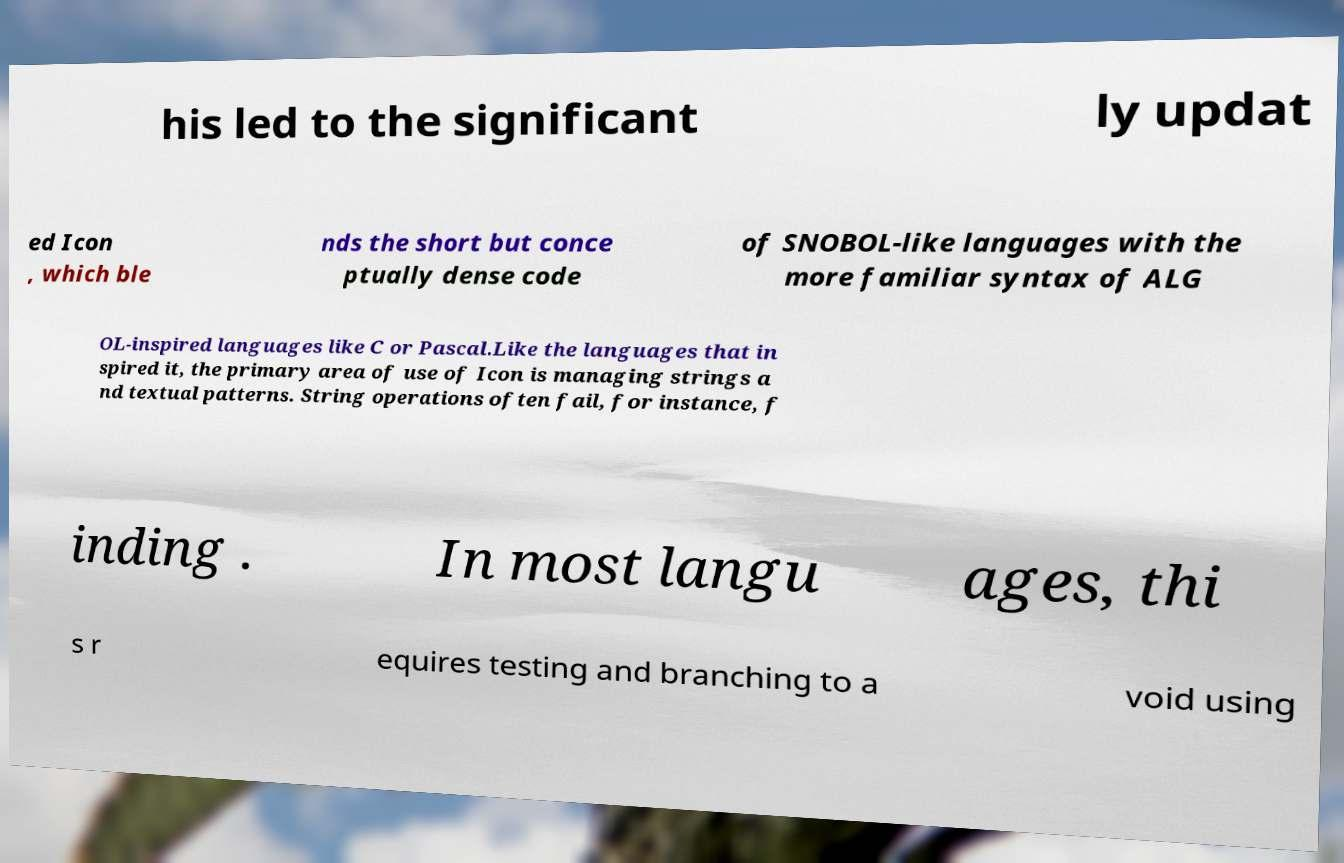There's text embedded in this image that I need extracted. Can you transcribe it verbatim? his led to the significant ly updat ed Icon , which ble nds the short but conce ptually dense code of SNOBOL-like languages with the more familiar syntax of ALG OL-inspired languages like C or Pascal.Like the languages that in spired it, the primary area of use of Icon is managing strings a nd textual patterns. String operations often fail, for instance, f inding . In most langu ages, thi s r equires testing and branching to a void using 